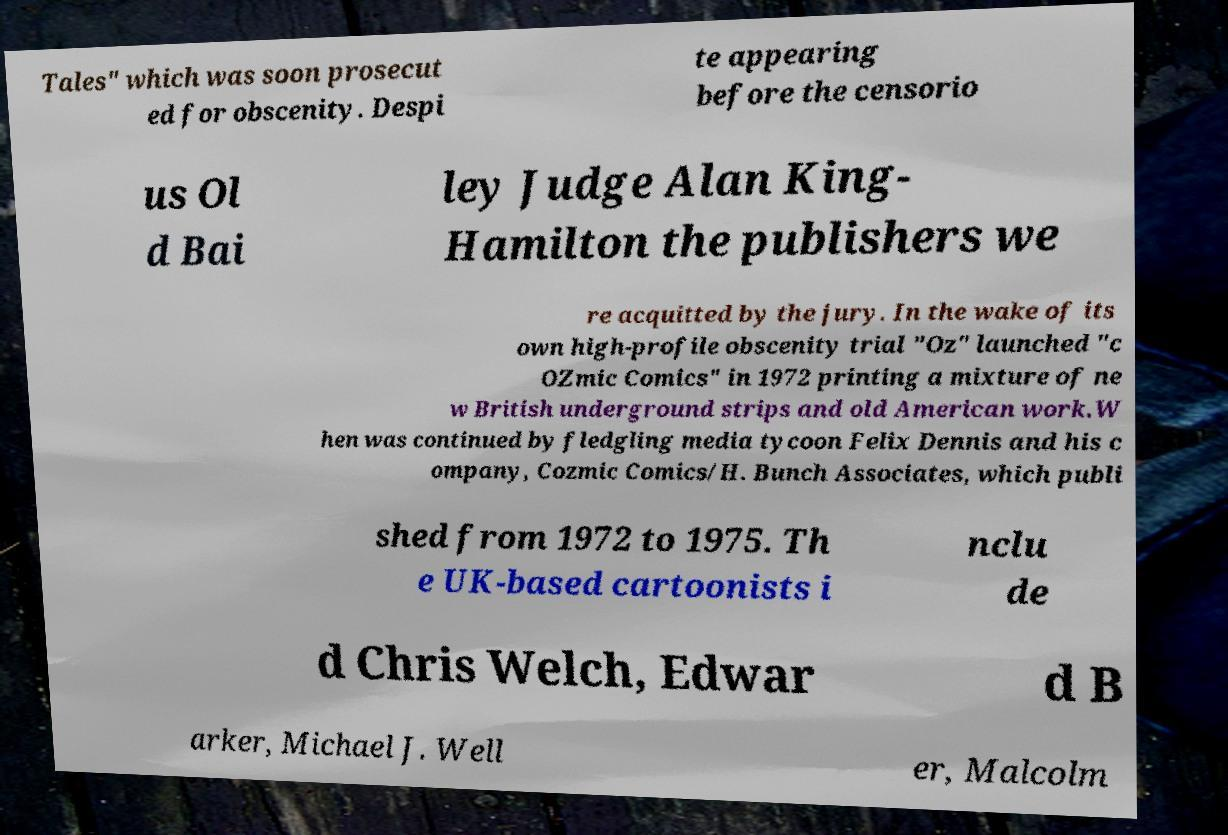Could you extract and type out the text from this image? Tales" which was soon prosecut ed for obscenity. Despi te appearing before the censorio us Ol d Bai ley Judge Alan King- Hamilton the publishers we re acquitted by the jury. In the wake of its own high-profile obscenity trial "Oz" launched "c OZmic Comics" in 1972 printing a mixture of ne w British underground strips and old American work.W hen was continued by fledgling media tycoon Felix Dennis and his c ompany, Cozmic Comics/H. Bunch Associates, which publi shed from 1972 to 1975. Th e UK-based cartoonists i nclu de d Chris Welch, Edwar d B arker, Michael J. Well er, Malcolm 